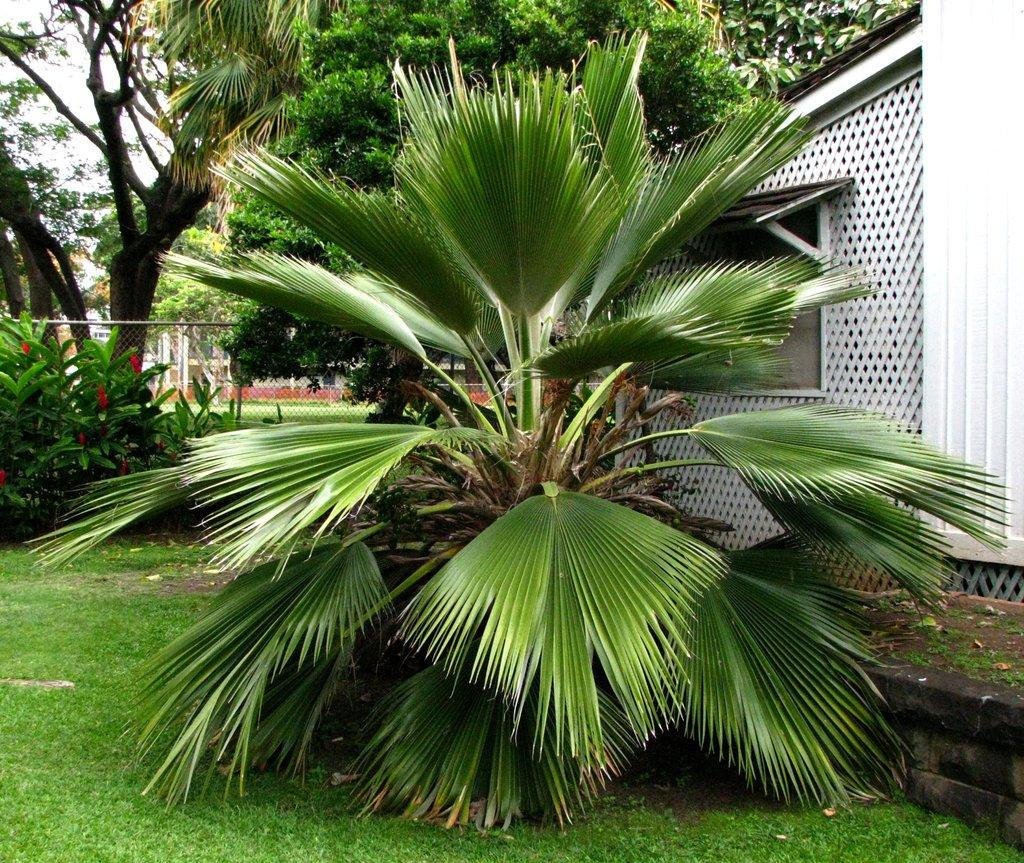What type of vegetation can be seen in the image? There are trees in the image. What type of barrier is present in the image? There is net fencing in the image. What type of structure is visible in the image? There is a building in the image. What architectural feature can be seen in the building? There is a window in the image. What type of ground cover is present in the image? There is green grass in the image. What is the color of the sky in the image? The sky appears to be white in color. Reasoning: Let's think step by step by step in order to produce the conversation. We start by identifying the main subjects and objects in the image based on the provided facts. We then formulate questions that focus on the location and characteristics of these subjects and objects, ensuring that each question can be answered definitively with the information given. We avoid yes/no questions and ensure that the language is simple and clear. Absurd Question/Answer: What type of arithmetic problem is being solved on the veil in the image? There is no veil or arithmetic problem present in the image. What type of lace pattern can be seen on the trees in the image? There is no lace pattern on the trees in the image; they are natural trees. What type of arithmetic problem is being solved on the veil in the image? There is no veil or arithmetic problem present in the image. 